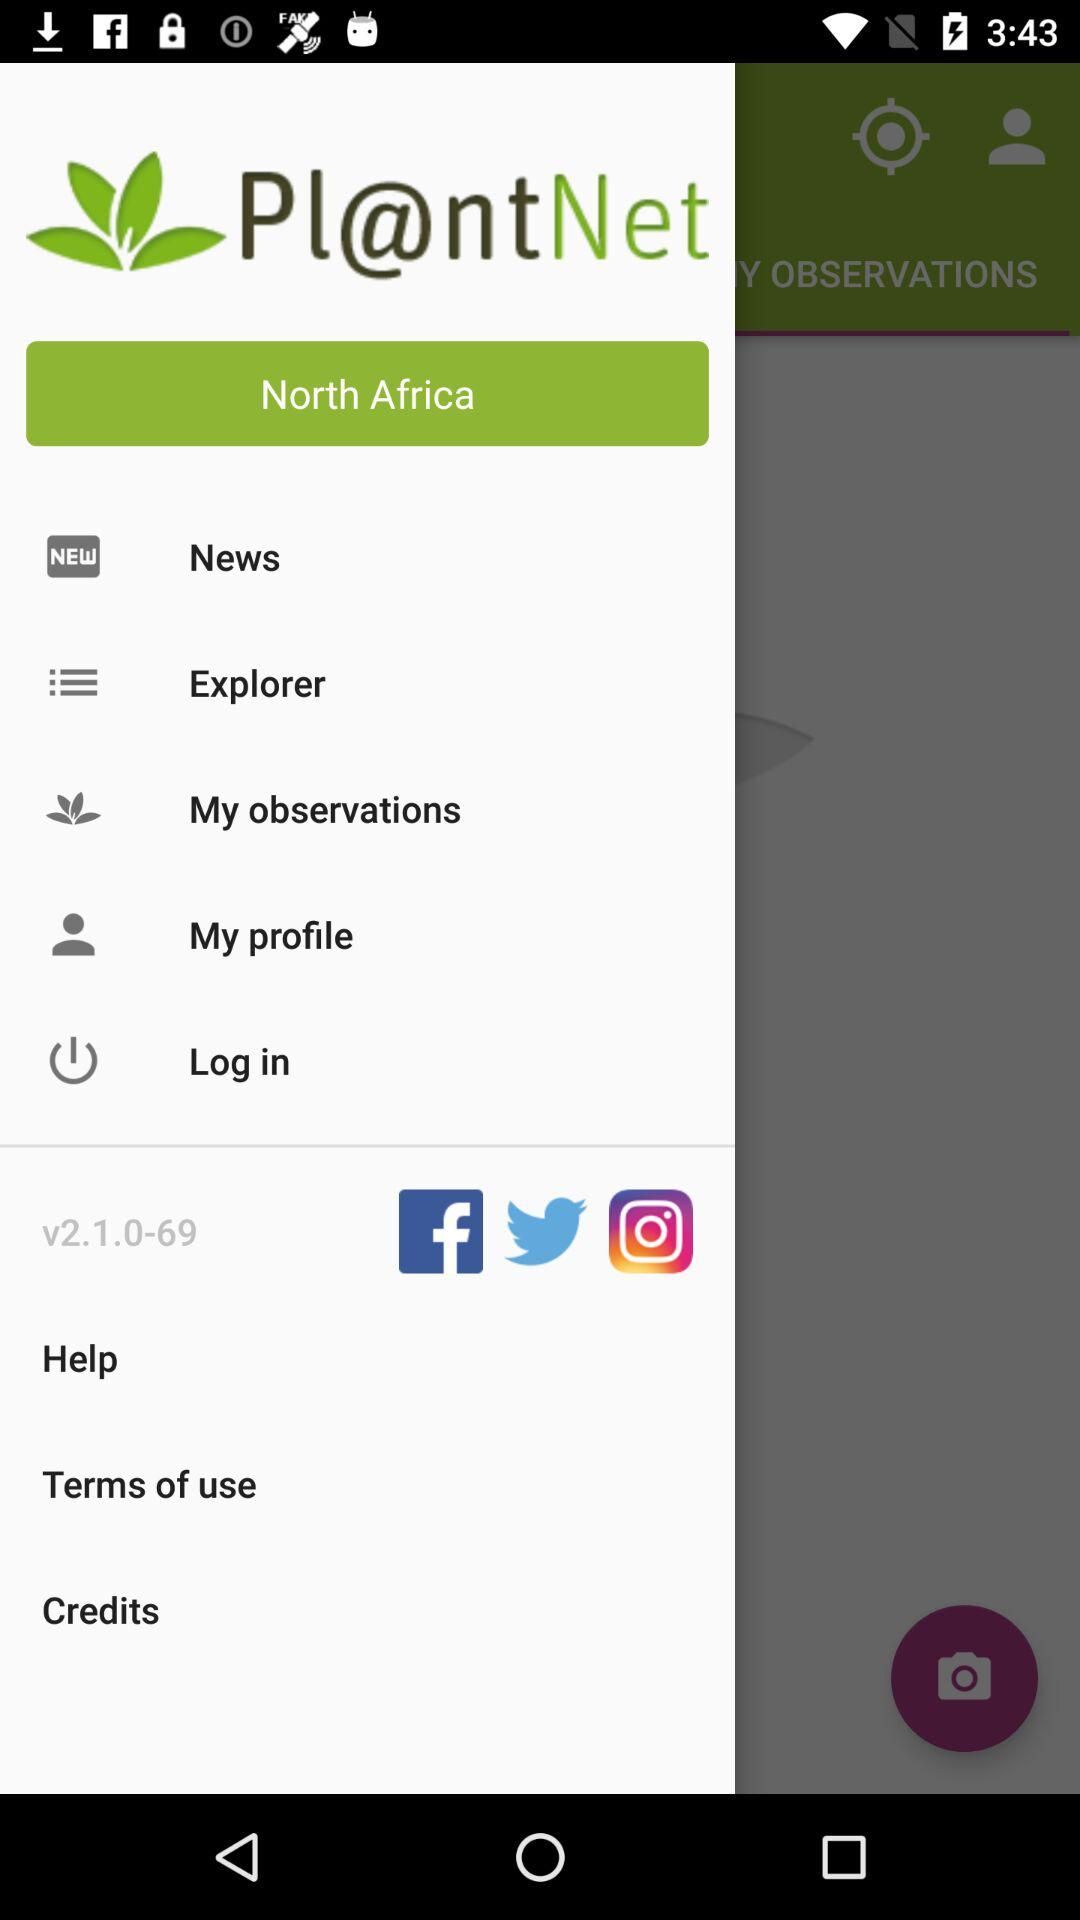Which version is used? The used version is v2.1.0-69. 